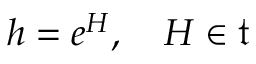<formula> <loc_0><loc_0><loc_500><loc_500>h = e ^ { H } , \quad H \in { \mathfrak { t } }</formula> 